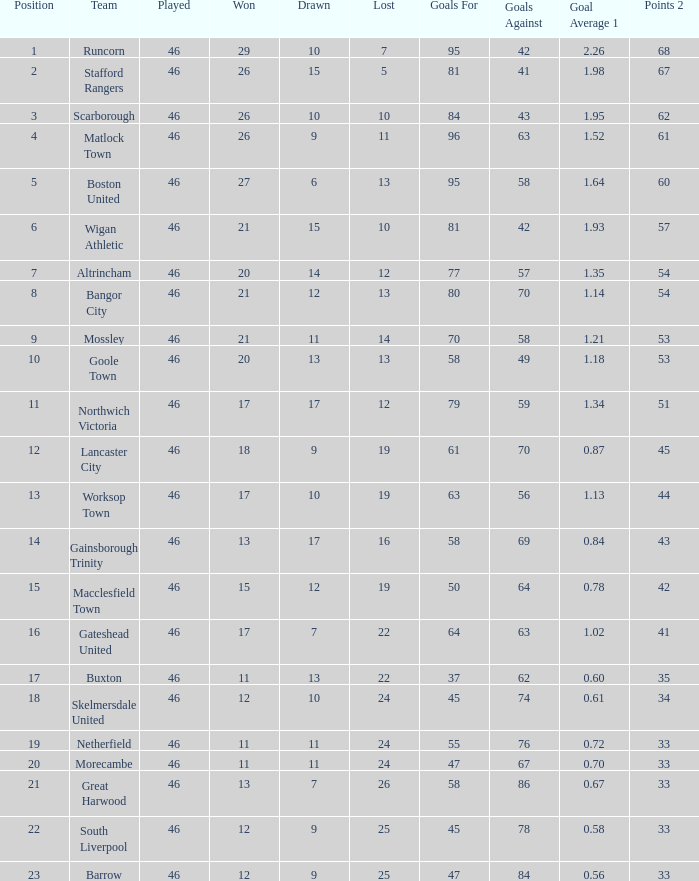Could you parse the entire table? {'header': ['Position', 'Team', 'Played', 'Won', 'Drawn', 'Lost', 'Goals For', 'Goals Against', 'Goal Average 1', 'Points 2'], 'rows': [['1', 'Runcorn', '46', '29', '10', '7', '95', '42', '2.26', '68'], ['2', 'Stafford Rangers', '46', '26', '15', '5', '81', '41', '1.98', '67'], ['3', 'Scarborough', '46', '26', '10', '10', '84', '43', '1.95', '62'], ['4', 'Matlock Town', '46', '26', '9', '11', '96', '63', '1.52', '61'], ['5', 'Boston United', '46', '27', '6', '13', '95', '58', '1.64', '60'], ['6', 'Wigan Athletic', '46', '21', '15', '10', '81', '42', '1.93', '57'], ['7', 'Altrincham', '46', '20', '14', '12', '77', '57', '1.35', '54'], ['8', 'Bangor City', '46', '21', '12', '13', '80', '70', '1.14', '54'], ['9', 'Mossley', '46', '21', '11', '14', '70', '58', '1.21', '53'], ['10', 'Goole Town', '46', '20', '13', '13', '58', '49', '1.18', '53'], ['11', 'Northwich Victoria', '46', '17', '17', '12', '79', '59', '1.34', '51'], ['12', 'Lancaster City', '46', '18', '9', '19', '61', '70', '0.87', '45'], ['13', 'Worksop Town', '46', '17', '10', '19', '63', '56', '1.13', '44'], ['14', 'Gainsborough Trinity', '46', '13', '17', '16', '58', '69', '0.84', '43'], ['15', 'Macclesfield Town', '46', '15', '12', '19', '50', '64', '0.78', '42'], ['16', 'Gateshead United', '46', '17', '7', '22', '64', '63', '1.02', '41'], ['17', 'Buxton', '46', '11', '13', '22', '37', '62', '0.60', '35'], ['18', 'Skelmersdale United', '46', '12', '10', '24', '45', '74', '0.61', '34'], ['19', 'Netherfield', '46', '11', '11', '24', '55', '76', '0.72', '33'], ['20', 'Morecambe', '46', '11', '11', '24', '47', '67', '0.70', '33'], ['21', 'Great Harwood', '46', '13', '7', '26', '58', '86', '0.67', '33'], ['22', 'South Liverpool', '46', '12', '9', '25', '45', '78', '0.58', '33'], ['23', 'Barrow', '46', '12', '9', '25', '47', '84', '0.56', '33']]} How many times did the Lancaster City team play? 1.0. 